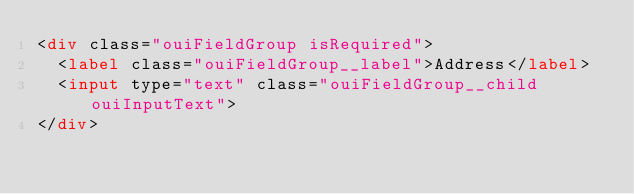Convert code to text. <code><loc_0><loc_0><loc_500><loc_500><_HTML_><div class="ouiFieldGroup isRequired">
  <label class="ouiFieldGroup__label">Address</label>
  <input type="text" class="ouiFieldGroup__child ouiInputText">
</div>
</code> 